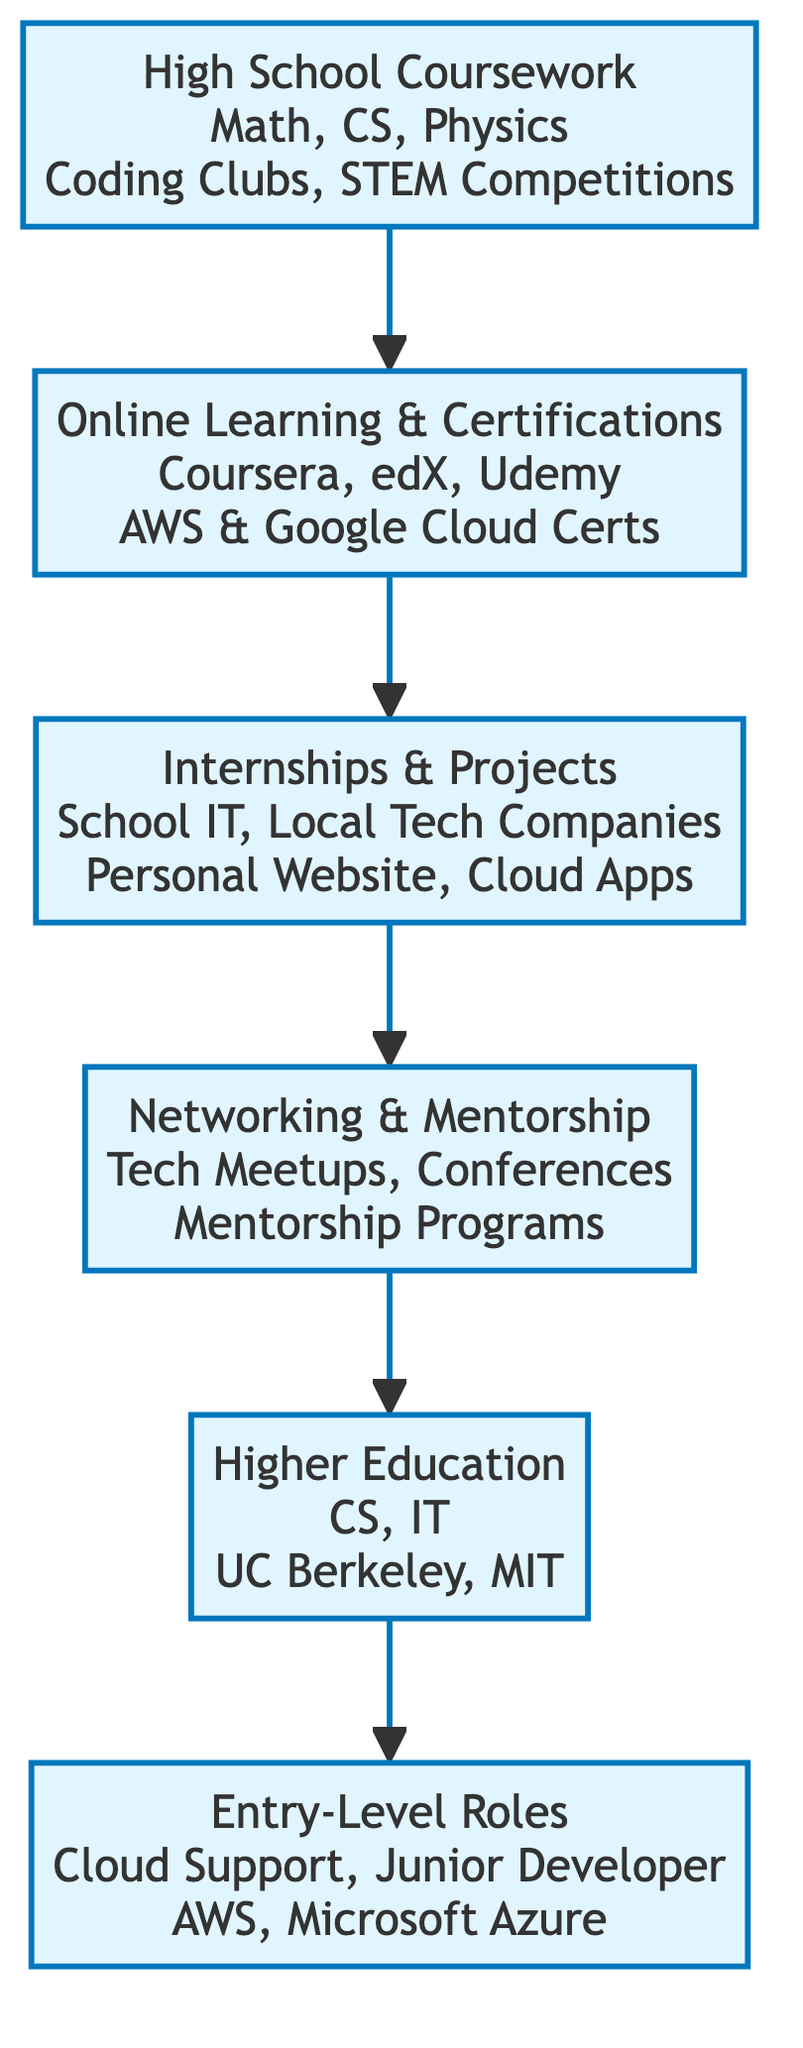What's the first step in the journey to a cloud computing career? The diagram indicates that the first step is "High School Coursework," which focuses on foundational subjects and extracurricular activities critical for developing relevant skills.
Answer: High School Coursework How many main steps are in the journey? By counting the nodes in the diagram, there are six primary steps outlined in the journey to a cloud computing career.
Answer: Six What is one activity recommended during high school? According to the diagram, one of the activities suggested during high school is "Coding Clubs," which helps foster coding skills and peer collaboration.
Answer: Coding Clubs Which platforms are suggested for online learning? The diagram lists "Coursera," "edX," and "Udemy" as recommended platforms for obtaining additional knowledge and credentials through online courses.
Answer: Coursera, edX, Udemy What type of roles can be pursued after higher education? The diagram specifies "Cloud Support Associate" and "Junior Cloud Developer" as potential entry-level roles that one can pursue after obtaining higher education in the relevant fields.
Answer: Cloud Support Associate, Junior Cloud Developer What is the recommended field of study in higher education? The diagram highlights "Computer Science" and "Information Technology" as the key fields of study for higher education that align well with a career in cloud computing.
Answer: Computer Science, Information Technology Which companies are listed for entry-level roles? The diagram mentions "Amazon Web Services" and "Microsoft Azure" as companies offering entry-level positions in the cloud computing field.
Answer: Amazon Web Services, Microsoft Azure What type of projects are suggested to gain practical experience? The diagram points out that students should engage in "Building a Personal Website" and "Creating Cloud-based Applications" as practical projects that help gain hands-on experience.
Answer: Building a Personal Website, Creating Cloud-based Applications What is the focus of networking in this journey? The diagram states that "Networking and Mentorship" is crucial, focusing on attending "Tech Meetups" and engaging in "Mentorship Programs" to build professional relationships and gain insights.
Answer: Networking and Mentorship 